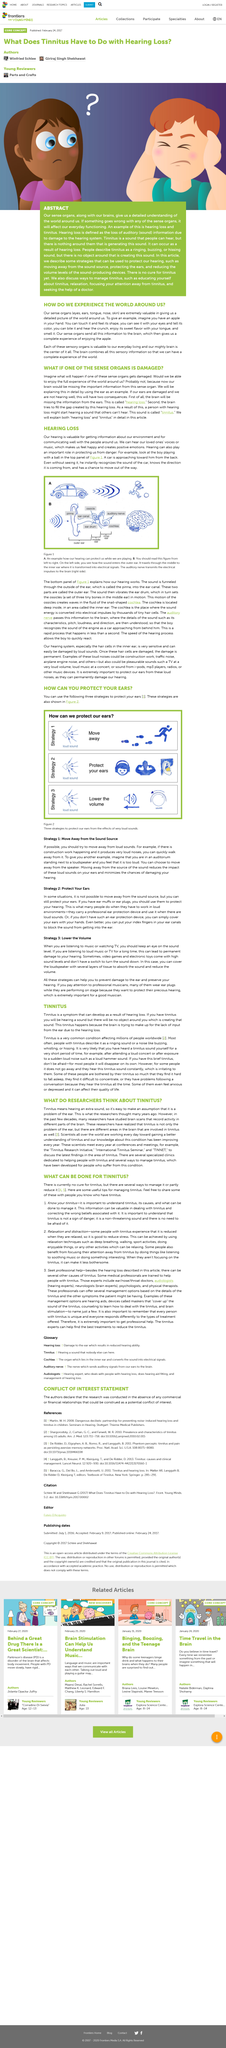Draw attention to some important aspects in this diagram. Our sense organs include the eyes, ears, tongue, nose, and skin, which collectively enable us to perceive and experience the world around us. Our hearing is valuable for obtaining information about our surroundings and for communicating effectively with those close to us. The figure that depicts a car is shown in option A. The sense organs submit information to the brain, which then processes and interprets the information to provide a complete experience. To effectively manage tinnitus, it is crucial to gain a comprehensive understanding of the condition, including its causes and appropriate management strategies. 